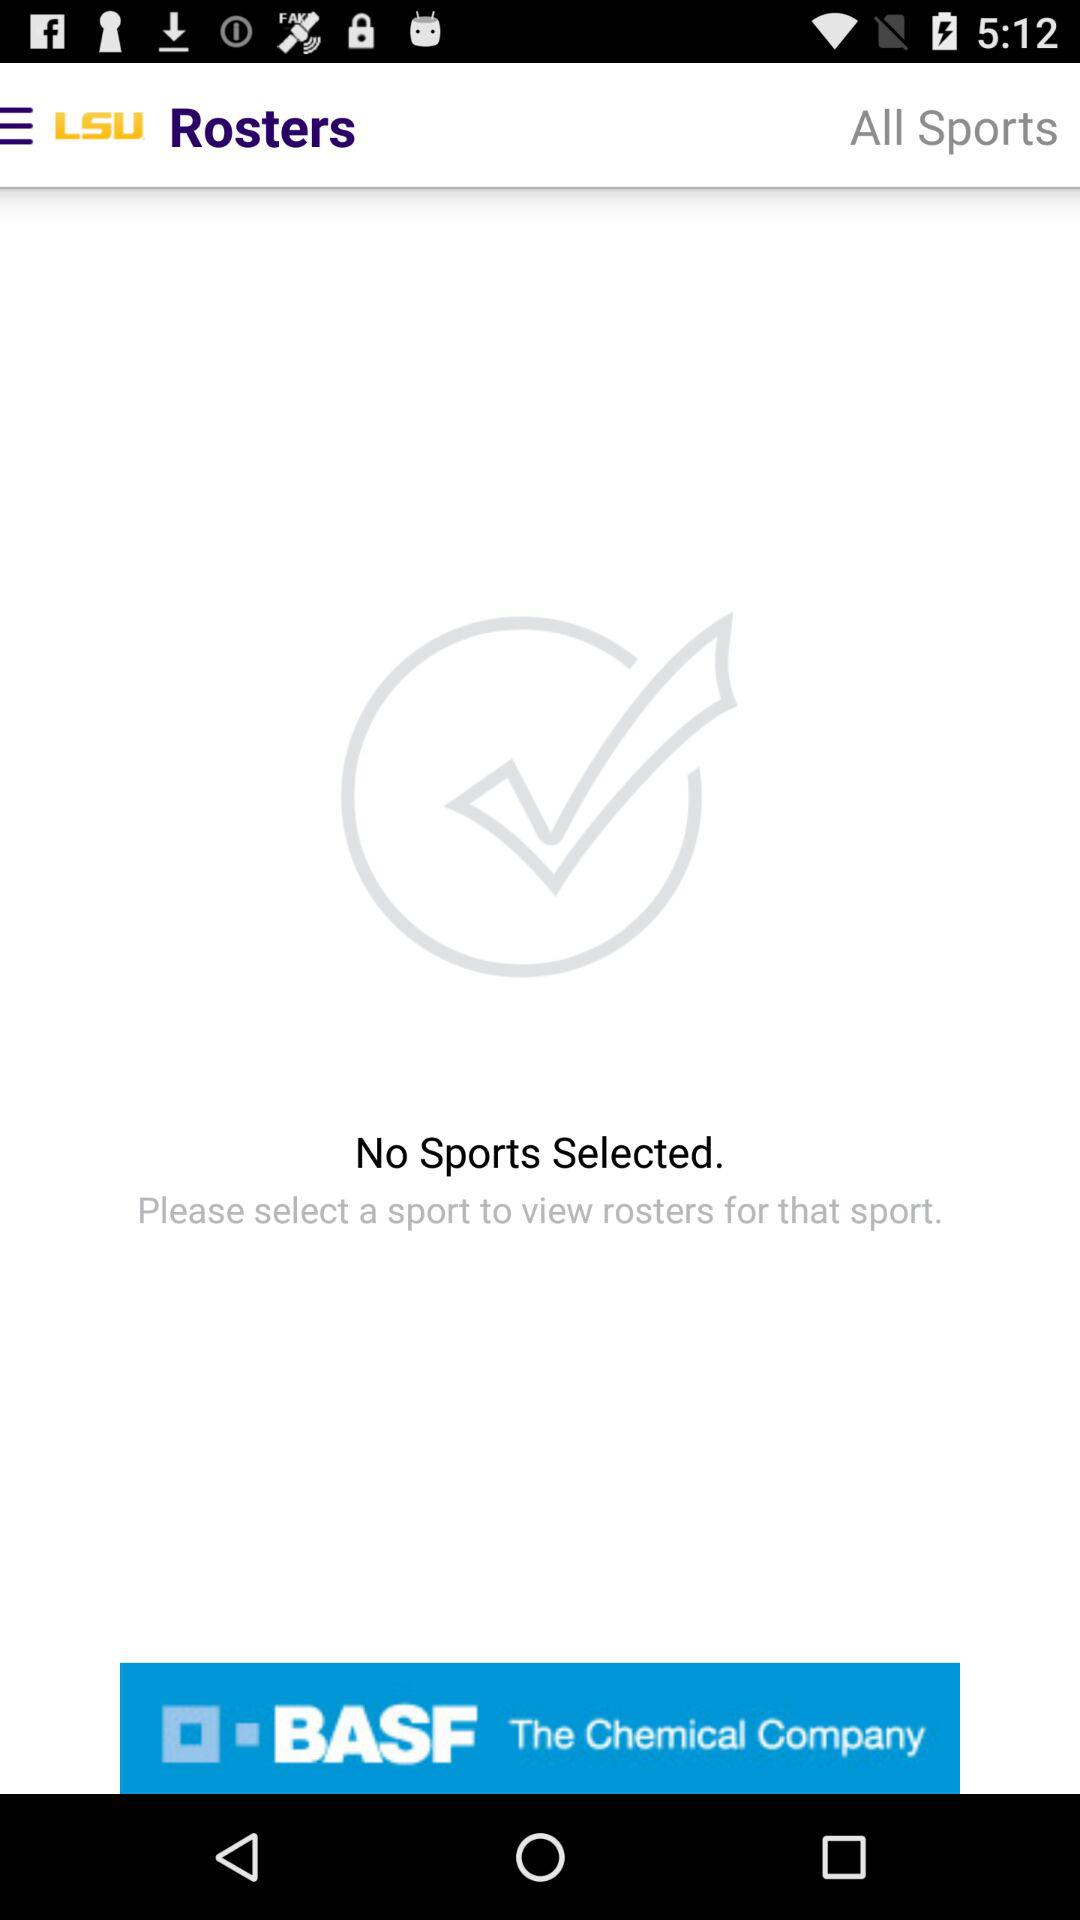What is the application name? The application name is "LSU". 